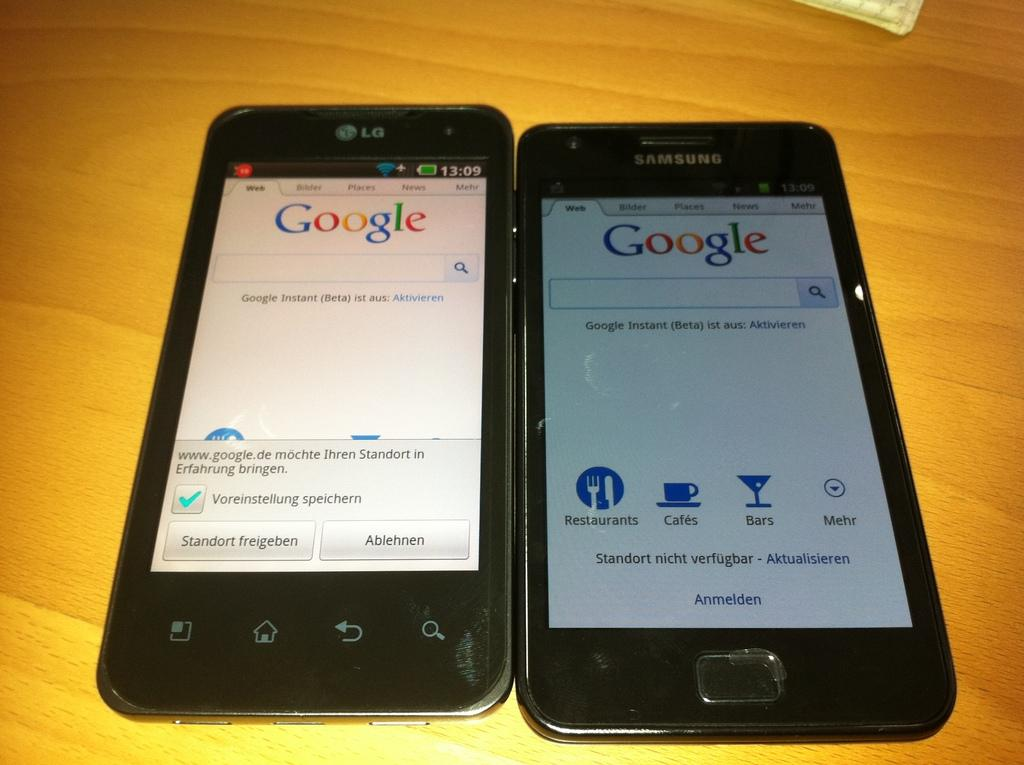Provide a one-sentence caption for the provided image. A black LG smartphone side by side a Samsung black smartphone on a wood table. 